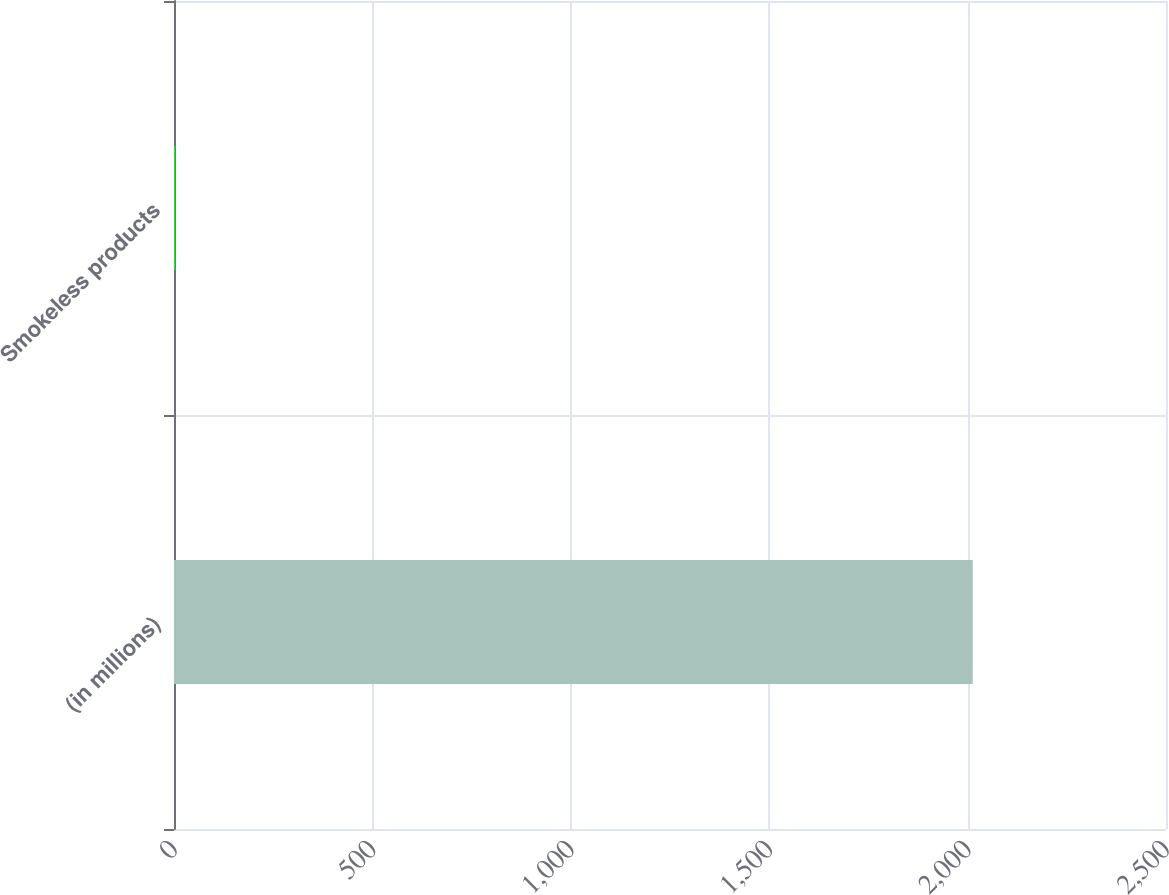Convert chart. <chart><loc_0><loc_0><loc_500><loc_500><bar_chart><fcel>(in millions)<fcel>Smokeless products<nl><fcel>2013<fcel>3<nl></chart> 